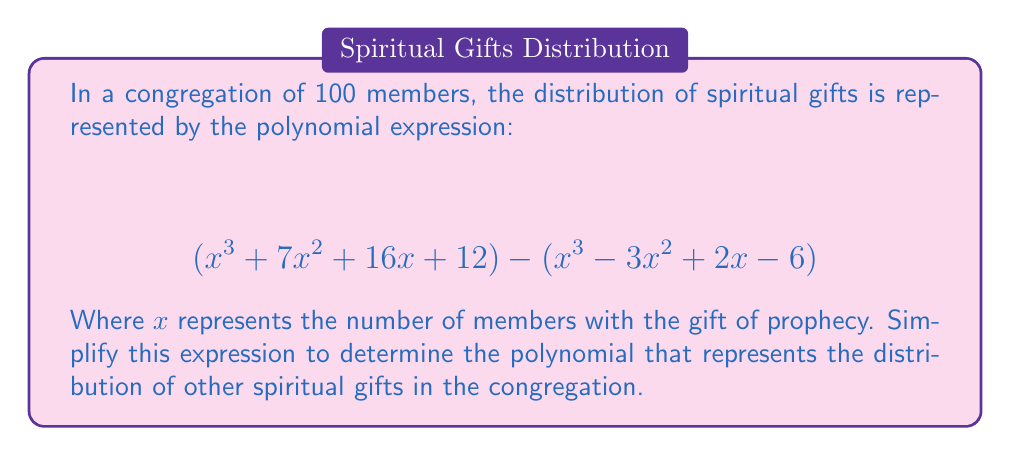Can you answer this question? To simplify this polynomial expression, we need to subtract the second polynomial from the first. Let's approach this step-by-step:

1) First, let's identify the two polynomials:
   $P_1 = x^3 + 7x^2 + 16x + 12$
   $P_2 = x^3 - 3x^2 + 2x - 6$

2) We need to subtract $P_2$ from $P_1$. When subtracting polynomials, we subtract the coefficients of like terms:

   $$(x^3 + 7x^2 + 16x + 12) - (x^3 - 3x^2 + 2x - 6)$$

3) Subtracting the terms:

   - For $x^3$ terms: $x^3 - x^3 = 0$
   - For $x^2$ terms: $7x^2 - (-3x^2) = 7x^2 + 3x^2 = 10x^2$
   - For $x$ terms: $16x - 2x = 14x$
   - For constant terms: $12 - (-6) = 12 + 6 = 18$

4) Combining these results:

   $$0 + 10x^2 + 14x + 18$$

5) Simplify by removing the zero term:

   $$10x^2 + 14x + 18$$

This simplified polynomial represents the distribution of other spiritual gifts in the congregation, where $x$ is the number of members with the gift of prophecy.
Answer: $$10x^2 + 14x + 18$$ 